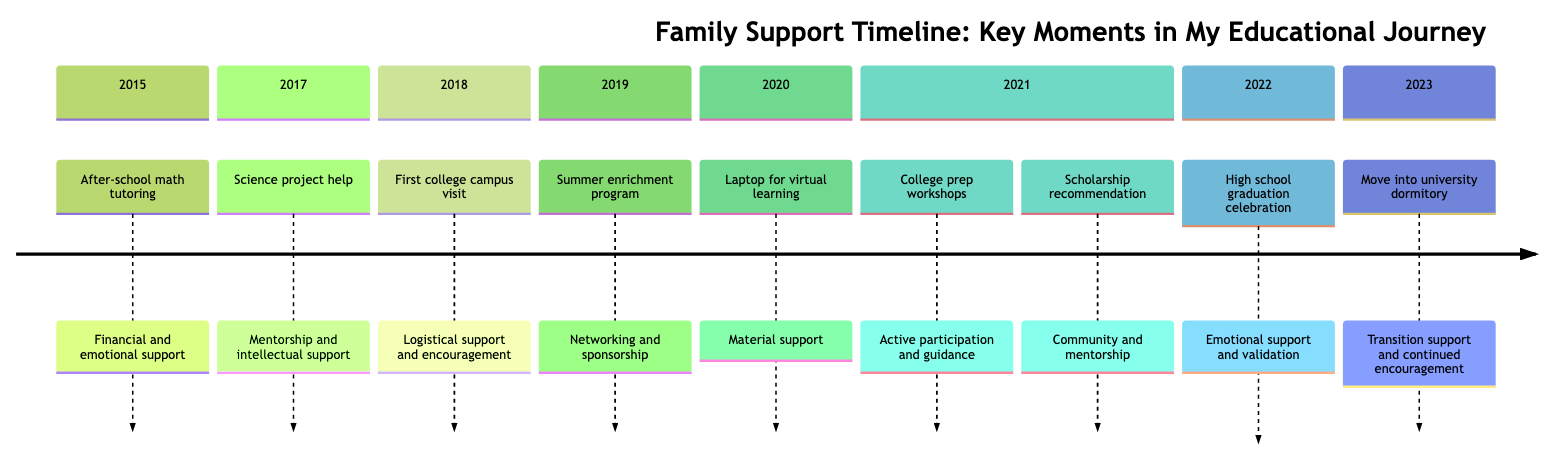What year did my parents enroll me in an after-school math tutoring program? The timeline indicates that the enrollment in an after-school math tutoring program occurred in 2015.
Answer: 2015 What contribution did my grandparents make in 2020? In 2020, the contribution from my grandparents included gifting a laptop for my high school studies, aiding in my virtual learning success.
Answer: Material support How many key moments in my educational journey are listed? By examining the timeline, there are a total of nine key moments described in the timeline.
Answer: 9 Which year features both college prep workshops and a scholarship recommendation? The year 2021 has two important events marked: my parents attending college prep workshops and receiving a scholarship recommendation.
Answer: 2021 What type of support did my family provide during my first college campus visit in 2018? The support during the 2018 college campus visit included logistical support and encouragement, helping to inspire my pursuit of higher education.
Answer: Logistical support and encouragement Which family member helped with science projects in 2017? The timeline specifically describes my older sibling as the family member who assisted me with science projects in 2017.
Answer: Older sibling In what year did my family celebrate my high school graduation? According to the timeline, my family celebrated my high school graduation in the year 2022.
Answer: 2022 What is the final action my parents provided in the timeline? The timeline concludes with my parents helping me move into my university dormitory in 2023, marking the start of my higher education journey.
Answer: Move into university dormitory What type of support did I receive in 2019 when I participated in a summer enrichment program? The timeline indicates that the type of support in 2019 was networking and sponsorship from family friends who sponsored my participation in the program.
Answer: Networking and sponsorship 